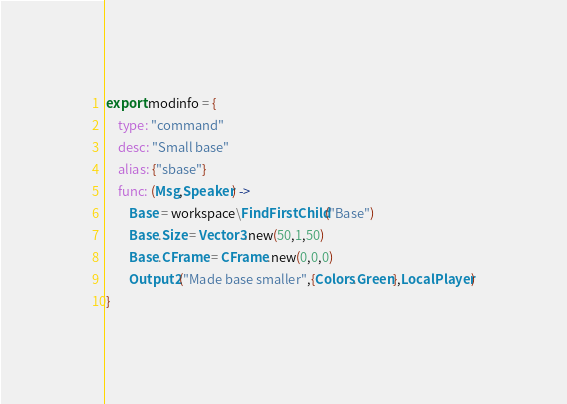Convert code to text. <code><loc_0><loc_0><loc_500><loc_500><_MoonScript_>export modinfo = {
	type: "command"
	desc: "Small base"
	alias: {"sbase"}
	func: (Msg,Speaker) ->
		Base = workspace\FindFirstChild("Base")
		Base.Size = Vector3.new(50,1,50)
		Base.CFrame = CFrame.new(0,0,0)
		Output2("Made base smaller",{Colors.Green},LocalPlayer)
}</code> 